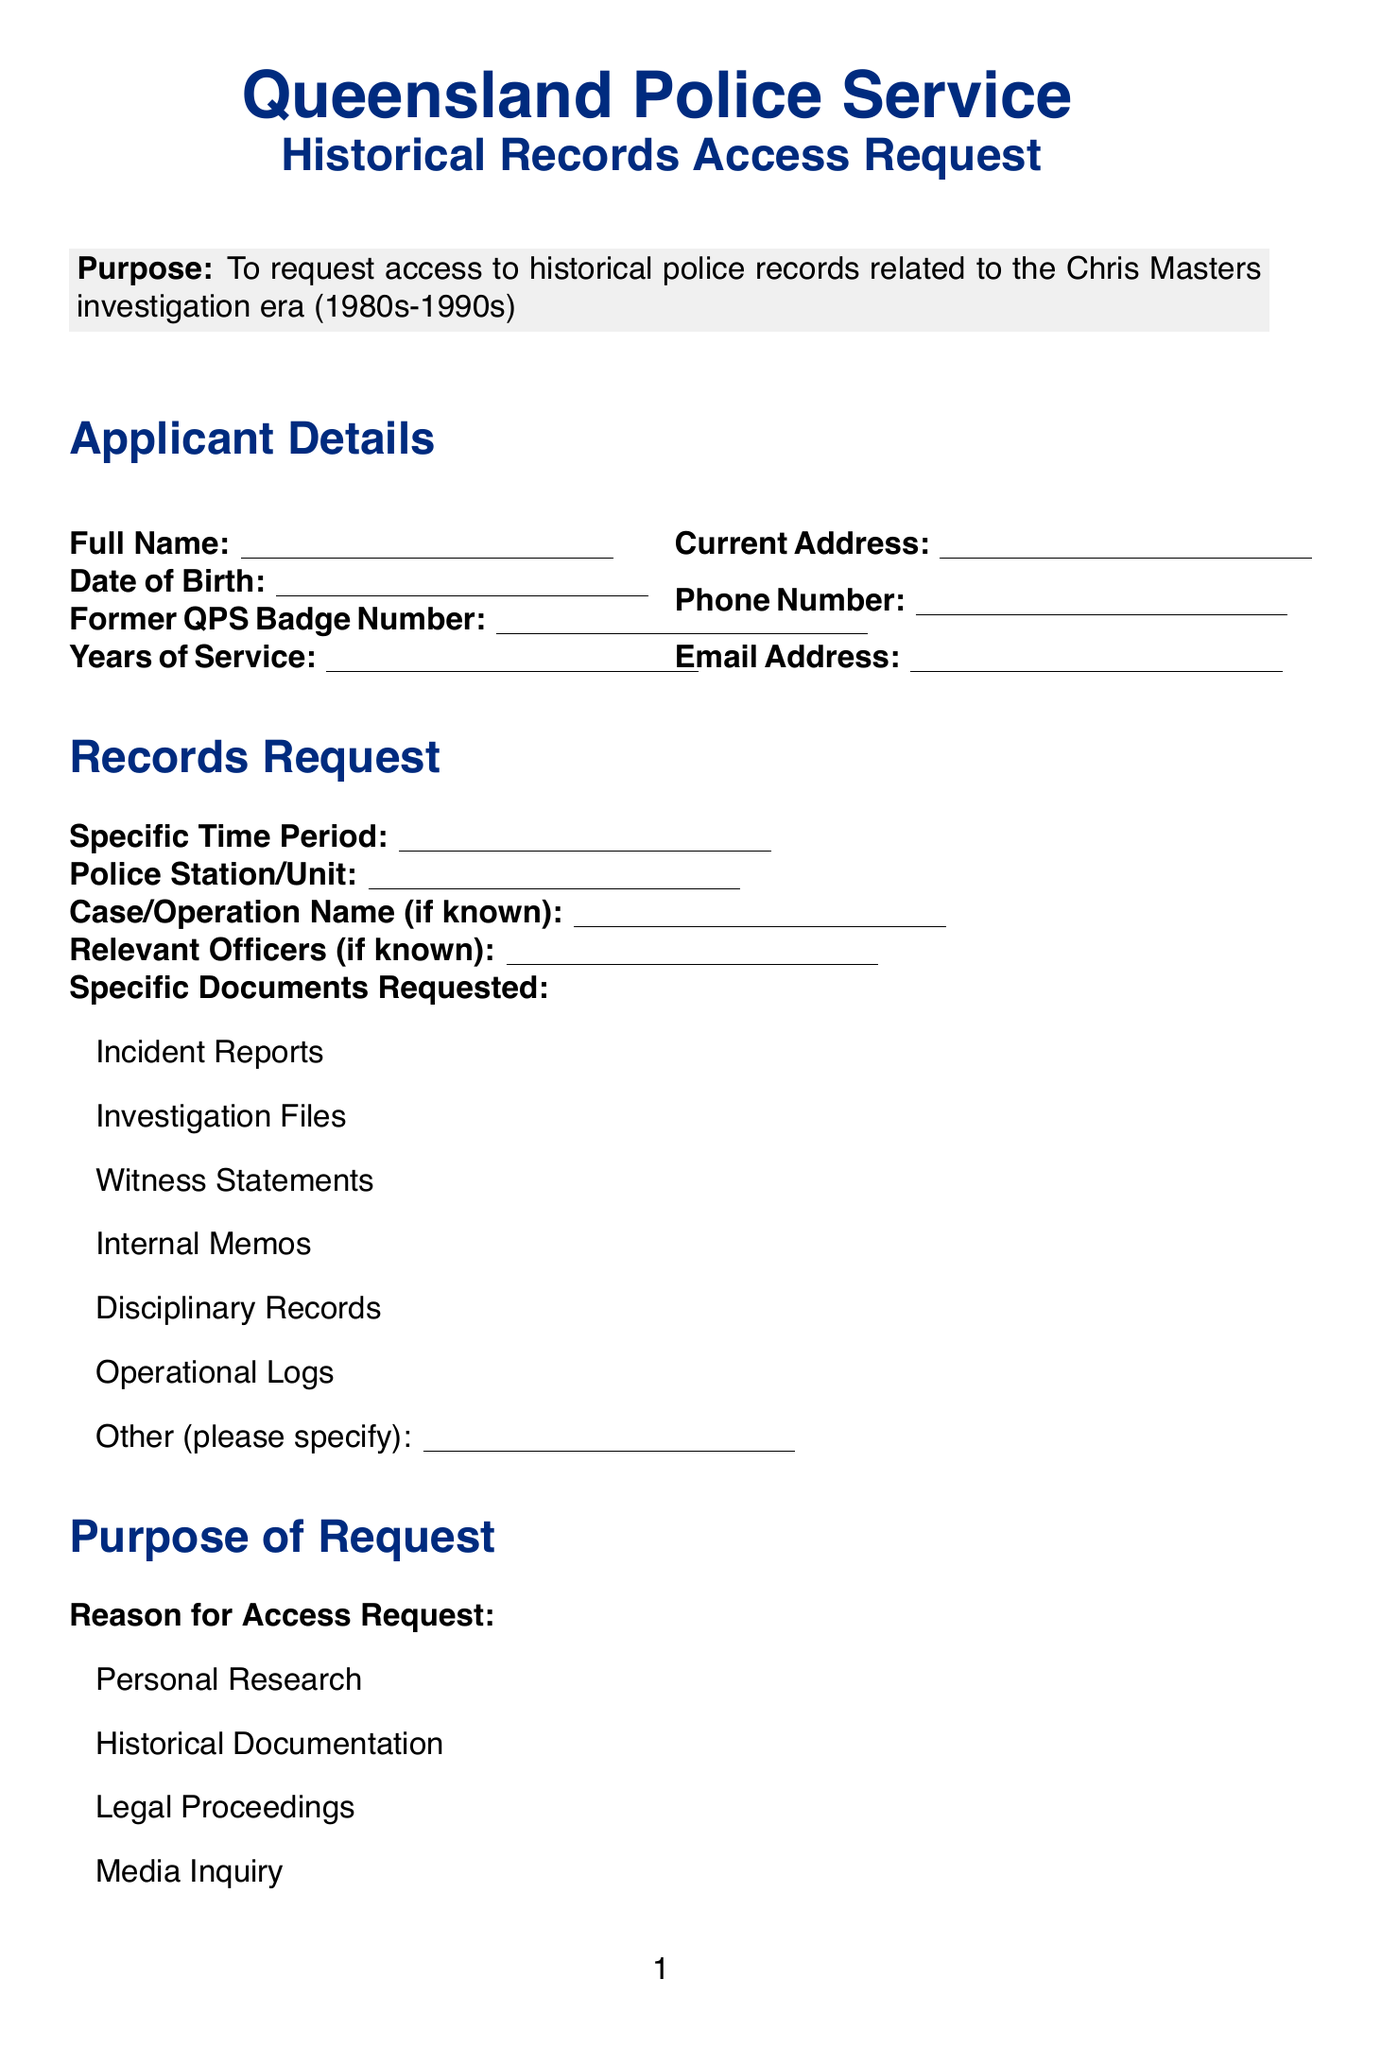what is the title of the form? The title of the form at the top of the document is given as "Queensland Police Service Historical Records Access Request".
Answer: Queensland Police Service Historical Records Access Request what is the purpose of the form? The purpose of the form is stated clearly in the document, explaining its intent to request access to specific historical records.
Answer: To request access to historical police records related to the Chris Masters investigation era (1980s-1990s) how many business days should be allowed for processing? The document specifies the time frame needed for processing the request.
Answer: 20-30 business days what is the processing fee mentioned? The document indicates a potential fee associated with the processing of requests.
Answer: $50 AUD what is one of the required fields for applicant details? The document lists various fields; one example is provided to highlight the type of information requested.
Answer: Full Name what are two types of specific documents requested? The document includes various options for types of records that can be requested, showing the diversity of documents.
Answer: Incident Reports, Investigation Files what is the contact information for inquiries? The document includes specific contact details for follow-up questions regarding the form submission.
Answer: foi@police.qld.gov.au what does the declaration checkbox state? The document lists several important declarations requiring acknowledgment by the applicant.
Answer: I understand that some records may be redacted or withheld due to ongoing investigations, privacy concerns, or national security issues what is one reason for the access request mentioned? The document outlines several reasons for requesting access, indicating that applicants must select from these options.
Answer: Personal Research 